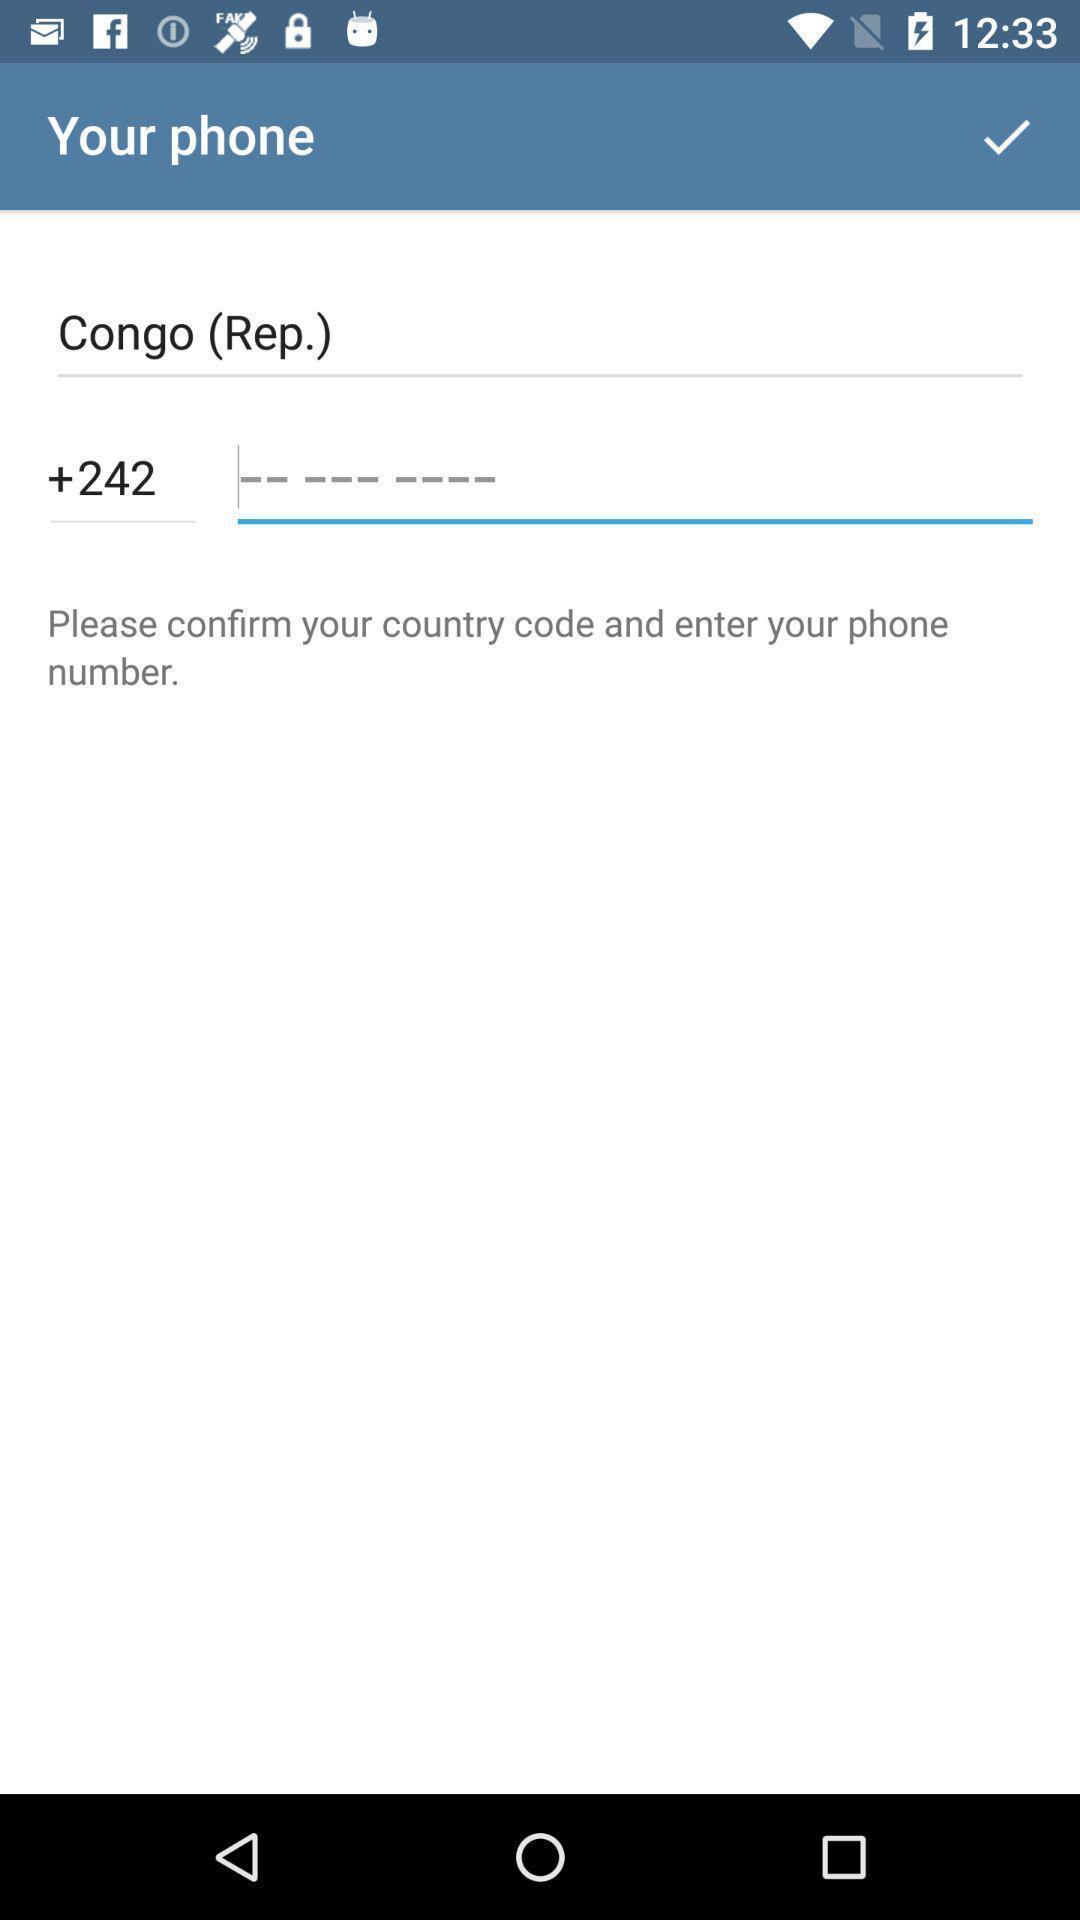Describe this image in words. Text box to enter your mobile no to go ahead. 